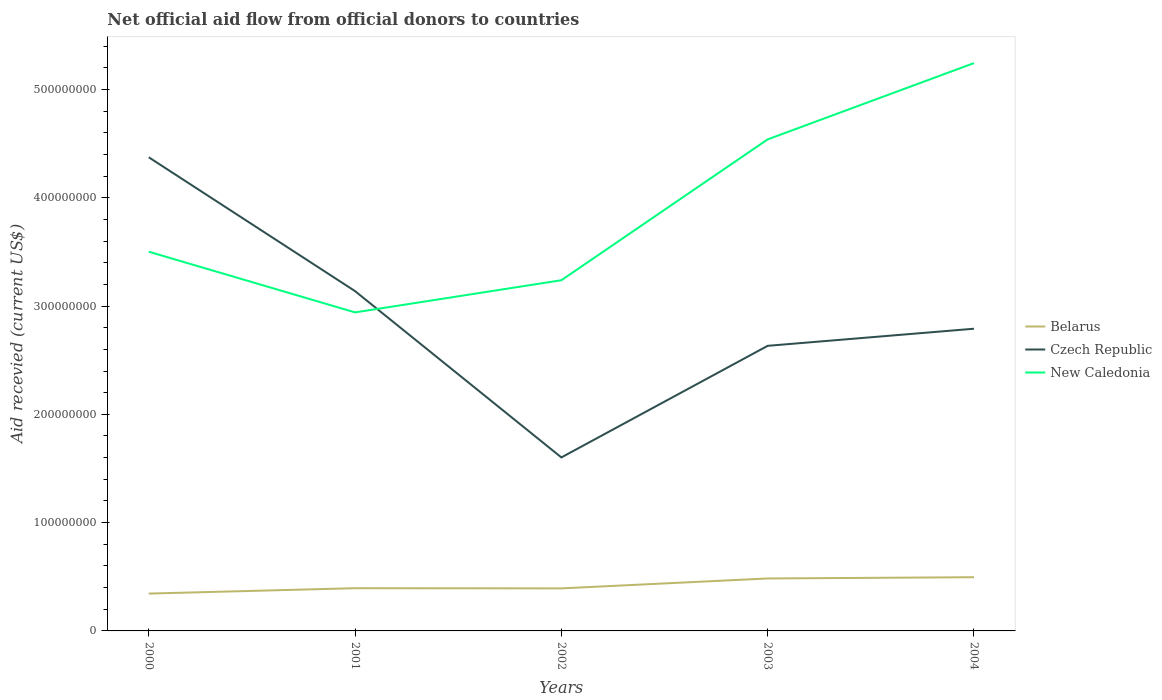Across all years, what is the maximum total aid received in Czech Republic?
Ensure brevity in your answer.  1.60e+08. What is the total total aid received in New Caledonia in the graph?
Ensure brevity in your answer.  -2.01e+08. What is the difference between the highest and the second highest total aid received in Belarus?
Give a very brief answer. 1.51e+07. Is the total aid received in Czech Republic strictly greater than the total aid received in Belarus over the years?
Your response must be concise. No. How many years are there in the graph?
Offer a very short reply. 5. What is the difference between two consecutive major ticks on the Y-axis?
Make the answer very short. 1.00e+08. Are the values on the major ticks of Y-axis written in scientific E-notation?
Give a very brief answer. No. Where does the legend appear in the graph?
Ensure brevity in your answer.  Center right. How are the legend labels stacked?
Make the answer very short. Vertical. What is the title of the graph?
Provide a short and direct response. Net official aid flow from official donors to countries. Does "Latin America(developing only)" appear as one of the legend labels in the graph?
Provide a succinct answer. No. What is the label or title of the Y-axis?
Offer a very short reply. Aid recevied (current US$). What is the Aid recevied (current US$) in Belarus in 2000?
Provide a succinct answer. 3.45e+07. What is the Aid recevied (current US$) of Czech Republic in 2000?
Give a very brief answer. 4.37e+08. What is the Aid recevied (current US$) in New Caledonia in 2000?
Offer a terse response. 3.50e+08. What is the Aid recevied (current US$) of Belarus in 2001?
Make the answer very short. 3.94e+07. What is the Aid recevied (current US$) of Czech Republic in 2001?
Your answer should be very brief. 3.14e+08. What is the Aid recevied (current US$) in New Caledonia in 2001?
Make the answer very short. 2.94e+08. What is the Aid recevied (current US$) of Belarus in 2002?
Your answer should be compact. 3.93e+07. What is the Aid recevied (current US$) in Czech Republic in 2002?
Your response must be concise. 1.60e+08. What is the Aid recevied (current US$) of New Caledonia in 2002?
Your response must be concise. 3.24e+08. What is the Aid recevied (current US$) of Belarus in 2003?
Give a very brief answer. 4.84e+07. What is the Aid recevied (current US$) of Czech Republic in 2003?
Offer a terse response. 2.63e+08. What is the Aid recevied (current US$) in New Caledonia in 2003?
Ensure brevity in your answer.  4.54e+08. What is the Aid recevied (current US$) in Belarus in 2004?
Offer a very short reply. 4.96e+07. What is the Aid recevied (current US$) of Czech Republic in 2004?
Give a very brief answer. 2.79e+08. What is the Aid recevied (current US$) in New Caledonia in 2004?
Provide a short and direct response. 5.24e+08. Across all years, what is the maximum Aid recevied (current US$) in Belarus?
Your answer should be very brief. 4.96e+07. Across all years, what is the maximum Aid recevied (current US$) of Czech Republic?
Your response must be concise. 4.37e+08. Across all years, what is the maximum Aid recevied (current US$) of New Caledonia?
Give a very brief answer. 5.24e+08. Across all years, what is the minimum Aid recevied (current US$) of Belarus?
Your answer should be very brief. 3.45e+07. Across all years, what is the minimum Aid recevied (current US$) in Czech Republic?
Offer a very short reply. 1.60e+08. Across all years, what is the minimum Aid recevied (current US$) of New Caledonia?
Give a very brief answer. 2.94e+08. What is the total Aid recevied (current US$) of Belarus in the graph?
Provide a short and direct response. 2.11e+08. What is the total Aid recevied (current US$) of Czech Republic in the graph?
Ensure brevity in your answer.  1.45e+09. What is the total Aid recevied (current US$) of New Caledonia in the graph?
Your response must be concise. 1.95e+09. What is the difference between the Aid recevied (current US$) of Belarus in 2000 and that in 2001?
Your response must be concise. -4.96e+06. What is the difference between the Aid recevied (current US$) in Czech Republic in 2000 and that in 2001?
Offer a terse response. 1.24e+08. What is the difference between the Aid recevied (current US$) of New Caledonia in 2000 and that in 2001?
Offer a very short reply. 5.60e+07. What is the difference between the Aid recevied (current US$) of Belarus in 2000 and that in 2002?
Offer a very short reply. -4.79e+06. What is the difference between the Aid recevied (current US$) in Czech Republic in 2000 and that in 2002?
Your answer should be very brief. 2.77e+08. What is the difference between the Aid recevied (current US$) in New Caledonia in 2000 and that in 2002?
Provide a short and direct response. 2.63e+07. What is the difference between the Aid recevied (current US$) of Belarus in 2000 and that in 2003?
Your response must be concise. -1.39e+07. What is the difference between the Aid recevied (current US$) in Czech Republic in 2000 and that in 2003?
Provide a succinct answer. 1.74e+08. What is the difference between the Aid recevied (current US$) of New Caledonia in 2000 and that in 2003?
Ensure brevity in your answer.  -1.04e+08. What is the difference between the Aid recevied (current US$) in Belarus in 2000 and that in 2004?
Your response must be concise. -1.51e+07. What is the difference between the Aid recevied (current US$) in Czech Republic in 2000 and that in 2004?
Offer a terse response. 1.58e+08. What is the difference between the Aid recevied (current US$) in New Caledonia in 2000 and that in 2004?
Ensure brevity in your answer.  -1.74e+08. What is the difference between the Aid recevied (current US$) of Belarus in 2001 and that in 2002?
Your answer should be compact. 1.70e+05. What is the difference between the Aid recevied (current US$) in Czech Republic in 2001 and that in 2002?
Keep it short and to the point. 1.54e+08. What is the difference between the Aid recevied (current US$) in New Caledonia in 2001 and that in 2002?
Your answer should be compact. -2.97e+07. What is the difference between the Aid recevied (current US$) in Belarus in 2001 and that in 2003?
Your answer should be compact. -8.98e+06. What is the difference between the Aid recevied (current US$) in Czech Republic in 2001 and that in 2003?
Keep it short and to the point. 5.05e+07. What is the difference between the Aid recevied (current US$) in New Caledonia in 2001 and that in 2003?
Your answer should be compact. -1.60e+08. What is the difference between the Aid recevied (current US$) of Belarus in 2001 and that in 2004?
Offer a terse response. -1.01e+07. What is the difference between the Aid recevied (current US$) in Czech Republic in 2001 and that in 2004?
Give a very brief answer. 3.47e+07. What is the difference between the Aid recevied (current US$) of New Caledonia in 2001 and that in 2004?
Provide a short and direct response. -2.30e+08. What is the difference between the Aid recevied (current US$) in Belarus in 2002 and that in 2003?
Give a very brief answer. -9.15e+06. What is the difference between the Aid recevied (current US$) in Czech Republic in 2002 and that in 2003?
Your response must be concise. -1.03e+08. What is the difference between the Aid recevied (current US$) of New Caledonia in 2002 and that in 2003?
Your response must be concise. -1.30e+08. What is the difference between the Aid recevied (current US$) in Belarus in 2002 and that in 2004?
Ensure brevity in your answer.  -1.03e+07. What is the difference between the Aid recevied (current US$) of Czech Republic in 2002 and that in 2004?
Provide a short and direct response. -1.19e+08. What is the difference between the Aid recevied (current US$) of New Caledonia in 2002 and that in 2004?
Give a very brief answer. -2.01e+08. What is the difference between the Aid recevied (current US$) in Belarus in 2003 and that in 2004?
Your answer should be compact. -1.16e+06. What is the difference between the Aid recevied (current US$) in Czech Republic in 2003 and that in 2004?
Your answer should be compact. -1.58e+07. What is the difference between the Aid recevied (current US$) in New Caledonia in 2003 and that in 2004?
Offer a very short reply. -7.04e+07. What is the difference between the Aid recevied (current US$) in Belarus in 2000 and the Aid recevied (current US$) in Czech Republic in 2001?
Keep it short and to the point. -2.79e+08. What is the difference between the Aid recevied (current US$) in Belarus in 2000 and the Aid recevied (current US$) in New Caledonia in 2001?
Offer a terse response. -2.60e+08. What is the difference between the Aid recevied (current US$) of Czech Republic in 2000 and the Aid recevied (current US$) of New Caledonia in 2001?
Provide a short and direct response. 1.43e+08. What is the difference between the Aid recevied (current US$) in Belarus in 2000 and the Aid recevied (current US$) in Czech Republic in 2002?
Give a very brief answer. -1.26e+08. What is the difference between the Aid recevied (current US$) of Belarus in 2000 and the Aid recevied (current US$) of New Caledonia in 2002?
Keep it short and to the point. -2.89e+08. What is the difference between the Aid recevied (current US$) of Czech Republic in 2000 and the Aid recevied (current US$) of New Caledonia in 2002?
Your answer should be compact. 1.14e+08. What is the difference between the Aid recevied (current US$) of Belarus in 2000 and the Aid recevied (current US$) of Czech Republic in 2003?
Your answer should be compact. -2.29e+08. What is the difference between the Aid recevied (current US$) of Belarus in 2000 and the Aid recevied (current US$) of New Caledonia in 2003?
Provide a short and direct response. -4.19e+08. What is the difference between the Aid recevied (current US$) in Czech Republic in 2000 and the Aid recevied (current US$) in New Caledonia in 2003?
Your response must be concise. -1.65e+07. What is the difference between the Aid recevied (current US$) in Belarus in 2000 and the Aid recevied (current US$) in Czech Republic in 2004?
Offer a terse response. -2.45e+08. What is the difference between the Aid recevied (current US$) of Belarus in 2000 and the Aid recevied (current US$) of New Caledonia in 2004?
Keep it short and to the point. -4.90e+08. What is the difference between the Aid recevied (current US$) in Czech Republic in 2000 and the Aid recevied (current US$) in New Caledonia in 2004?
Keep it short and to the point. -8.70e+07. What is the difference between the Aid recevied (current US$) of Belarus in 2001 and the Aid recevied (current US$) of Czech Republic in 2002?
Your response must be concise. -1.21e+08. What is the difference between the Aid recevied (current US$) in Belarus in 2001 and the Aid recevied (current US$) in New Caledonia in 2002?
Your response must be concise. -2.84e+08. What is the difference between the Aid recevied (current US$) in Czech Republic in 2001 and the Aid recevied (current US$) in New Caledonia in 2002?
Keep it short and to the point. -1.00e+07. What is the difference between the Aid recevied (current US$) of Belarus in 2001 and the Aid recevied (current US$) of Czech Republic in 2003?
Ensure brevity in your answer.  -2.24e+08. What is the difference between the Aid recevied (current US$) of Belarus in 2001 and the Aid recevied (current US$) of New Caledonia in 2003?
Your answer should be compact. -4.14e+08. What is the difference between the Aid recevied (current US$) of Czech Republic in 2001 and the Aid recevied (current US$) of New Caledonia in 2003?
Make the answer very short. -1.40e+08. What is the difference between the Aid recevied (current US$) of Belarus in 2001 and the Aid recevied (current US$) of Czech Republic in 2004?
Provide a succinct answer. -2.40e+08. What is the difference between the Aid recevied (current US$) in Belarus in 2001 and the Aid recevied (current US$) in New Caledonia in 2004?
Your answer should be compact. -4.85e+08. What is the difference between the Aid recevied (current US$) of Czech Republic in 2001 and the Aid recevied (current US$) of New Caledonia in 2004?
Provide a succinct answer. -2.11e+08. What is the difference between the Aid recevied (current US$) of Belarus in 2002 and the Aid recevied (current US$) of Czech Republic in 2003?
Provide a short and direct response. -2.24e+08. What is the difference between the Aid recevied (current US$) in Belarus in 2002 and the Aid recevied (current US$) in New Caledonia in 2003?
Ensure brevity in your answer.  -4.15e+08. What is the difference between the Aid recevied (current US$) in Czech Republic in 2002 and the Aid recevied (current US$) in New Caledonia in 2003?
Offer a terse response. -2.94e+08. What is the difference between the Aid recevied (current US$) of Belarus in 2002 and the Aid recevied (current US$) of Czech Republic in 2004?
Offer a very short reply. -2.40e+08. What is the difference between the Aid recevied (current US$) of Belarus in 2002 and the Aid recevied (current US$) of New Caledonia in 2004?
Ensure brevity in your answer.  -4.85e+08. What is the difference between the Aid recevied (current US$) of Czech Republic in 2002 and the Aid recevied (current US$) of New Caledonia in 2004?
Offer a terse response. -3.64e+08. What is the difference between the Aid recevied (current US$) of Belarus in 2003 and the Aid recevied (current US$) of Czech Republic in 2004?
Keep it short and to the point. -2.31e+08. What is the difference between the Aid recevied (current US$) of Belarus in 2003 and the Aid recevied (current US$) of New Caledonia in 2004?
Your response must be concise. -4.76e+08. What is the difference between the Aid recevied (current US$) of Czech Republic in 2003 and the Aid recevied (current US$) of New Caledonia in 2004?
Offer a terse response. -2.61e+08. What is the average Aid recevied (current US$) in Belarus per year?
Provide a succinct answer. 4.22e+07. What is the average Aid recevied (current US$) in Czech Republic per year?
Offer a very short reply. 2.91e+08. What is the average Aid recevied (current US$) of New Caledonia per year?
Your answer should be compact. 3.89e+08. In the year 2000, what is the difference between the Aid recevied (current US$) of Belarus and Aid recevied (current US$) of Czech Republic?
Provide a succinct answer. -4.03e+08. In the year 2000, what is the difference between the Aid recevied (current US$) of Belarus and Aid recevied (current US$) of New Caledonia?
Your answer should be very brief. -3.16e+08. In the year 2000, what is the difference between the Aid recevied (current US$) in Czech Republic and Aid recevied (current US$) in New Caledonia?
Your answer should be compact. 8.72e+07. In the year 2001, what is the difference between the Aid recevied (current US$) of Belarus and Aid recevied (current US$) of Czech Republic?
Offer a terse response. -2.74e+08. In the year 2001, what is the difference between the Aid recevied (current US$) in Belarus and Aid recevied (current US$) in New Caledonia?
Your response must be concise. -2.55e+08. In the year 2001, what is the difference between the Aid recevied (current US$) of Czech Republic and Aid recevied (current US$) of New Caledonia?
Give a very brief answer. 1.96e+07. In the year 2002, what is the difference between the Aid recevied (current US$) of Belarus and Aid recevied (current US$) of Czech Republic?
Your answer should be compact. -1.21e+08. In the year 2002, what is the difference between the Aid recevied (current US$) of Belarus and Aid recevied (current US$) of New Caledonia?
Offer a terse response. -2.85e+08. In the year 2002, what is the difference between the Aid recevied (current US$) of Czech Republic and Aid recevied (current US$) of New Caledonia?
Make the answer very short. -1.64e+08. In the year 2003, what is the difference between the Aid recevied (current US$) of Belarus and Aid recevied (current US$) of Czech Republic?
Make the answer very short. -2.15e+08. In the year 2003, what is the difference between the Aid recevied (current US$) of Belarus and Aid recevied (current US$) of New Caledonia?
Your answer should be very brief. -4.05e+08. In the year 2003, what is the difference between the Aid recevied (current US$) in Czech Republic and Aid recevied (current US$) in New Caledonia?
Give a very brief answer. -1.91e+08. In the year 2004, what is the difference between the Aid recevied (current US$) of Belarus and Aid recevied (current US$) of Czech Republic?
Your answer should be very brief. -2.29e+08. In the year 2004, what is the difference between the Aid recevied (current US$) in Belarus and Aid recevied (current US$) in New Caledonia?
Make the answer very short. -4.75e+08. In the year 2004, what is the difference between the Aid recevied (current US$) in Czech Republic and Aid recevied (current US$) in New Caledonia?
Provide a succinct answer. -2.45e+08. What is the ratio of the Aid recevied (current US$) in Belarus in 2000 to that in 2001?
Provide a short and direct response. 0.87. What is the ratio of the Aid recevied (current US$) in Czech Republic in 2000 to that in 2001?
Offer a terse response. 1.39. What is the ratio of the Aid recevied (current US$) of New Caledonia in 2000 to that in 2001?
Your answer should be compact. 1.19. What is the ratio of the Aid recevied (current US$) of Belarus in 2000 to that in 2002?
Offer a very short reply. 0.88. What is the ratio of the Aid recevied (current US$) of Czech Republic in 2000 to that in 2002?
Your answer should be compact. 2.73. What is the ratio of the Aid recevied (current US$) in New Caledonia in 2000 to that in 2002?
Make the answer very short. 1.08. What is the ratio of the Aid recevied (current US$) of Belarus in 2000 to that in 2003?
Your response must be concise. 0.71. What is the ratio of the Aid recevied (current US$) of Czech Republic in 2000 to that in 2003?
Your answer should be compact. 1.66. What is the ratio of the Aid recevied (current US$) of New Caledonia in 2000 to that in 2003?
Your answer should be very brief. 0.77. What is the ratio of the Aid recevied (current US$) of Belarus in 2000 to that in 2004?
Provide a succinct answer. 0.7. What is the ratio of the Aid recevied (current US$) of Czech Republic in 2000 to that in 2004?
Your response must be concise. 1.57. What is the ratio of the Aid recevied (current US$) of New Caledonia in 2000 to that in 2004?
Make the answer very short. 0.67. What is the ratio of the Aid recevied (current US$) in Belarus in 2001 to that in 2002?
Give a very brief answer. 1. What is the ratio of the Aid recevied (current US$) of Czech Republic in 2001 to that in 2002?
Provide a succinct answer. 1.96. What is the ratio of the Aid recevied (current US$) in New Caledonia in 2001 to that in 2002?
Your answer should be compact. 0.91. What is the ratio of the Aid recevied (current US$) of Belarus in 2001 to that in 2003?
Offer a very short reply. 0.81. What is the ratio of the Aid recevied (current US$) of Czech Republic in 2001 to that in 2003?
Your answer should be very brief. 1.19. What is the ratio of the Aid recevied (current US$) of New Caledonia in 2001 to that in 2003?
Give a very brief answer. 0.65. What is the ratio of the Aid recevied (current US$) in Belarus in 2001 to that in 2004?
Provide a short and direct response. 0.8. What is the ratio of the Aid recevied (current US$) of Czech Republic in 2001 to that in 2004?
Your answer should be very brief. 1.12. What is the ratio of the Aid recevied (current US$) in New Caledonia in 2001 to that in 2004?
Your answer should be compact. 0.56. What is the ratio of the Aid recevied (current US$) of Belarus in 2002 to that in 2003?
Your answer should be compact. 0.81. What is the ratio of the Aid recevied (current US$) of Czech Republic in 2002 to that in 2003?
Provide a succinct answer. 0.61. What is the ratio of the Aid recevied (current US$) of New Caledonia in 2002 to that in 2003?
Your answer should be compact. 0.71. What is the ratio of the Aid recevied (current US$) of Belarus in 2002 to that in 2004?
Provide a short and direct response. 0.79. What is the ratio of the Aid recevied (current US$) of Czech Republic in 2002 to that in 2004?
Provide a short and direct response. 0.57. What is the ratio of the Aid recevied (current US$) of New Caledonia in 2002 to that in 2004?
Your response must be concise. 0.62. What is the ratio of the Aid recevied (current US$) in Belarus in 2003 to that in 2004?
Ensure brevity in your answer.  0.98. What is the ratio of the Aid recevied (current US$) of Czech Republic in 2003 to that in 2004?
Provide a succinct answer. 0.94. What is the ratio of the Aid recevied (current US$) in New Caledonia in 2003 to that in 2004?
Ensure brevity in your answer.  0.87. What is the difference between the highest and the second highest Aid recevied (current US$) of Belarus?
Offer a terse response. 1.16e+06. What is the difference between the highest and the second highest Aid recevied (current US$) of Czech Republic?
Provide a short and direct response. 1.24e+08. What is the difference between the highest and the second highest Aid recevied (current US$) of New Caledonia?
Your answer should be compact. 7.04e+07. What is the difference between the highest and the lowest Aid recevied (current US$) in Belarus?
Give a very brief answer. 1.51e+07. What is the difference between the highest and the lowest Aid recevied (current US$) in Czech Republic?
Provide a succinct answer. 2.77e+08. What is the difference between the highest and the lowest Aid recevied (current US$) in New Caledonia?
Keep it short and to the point. 2.30e+08. 